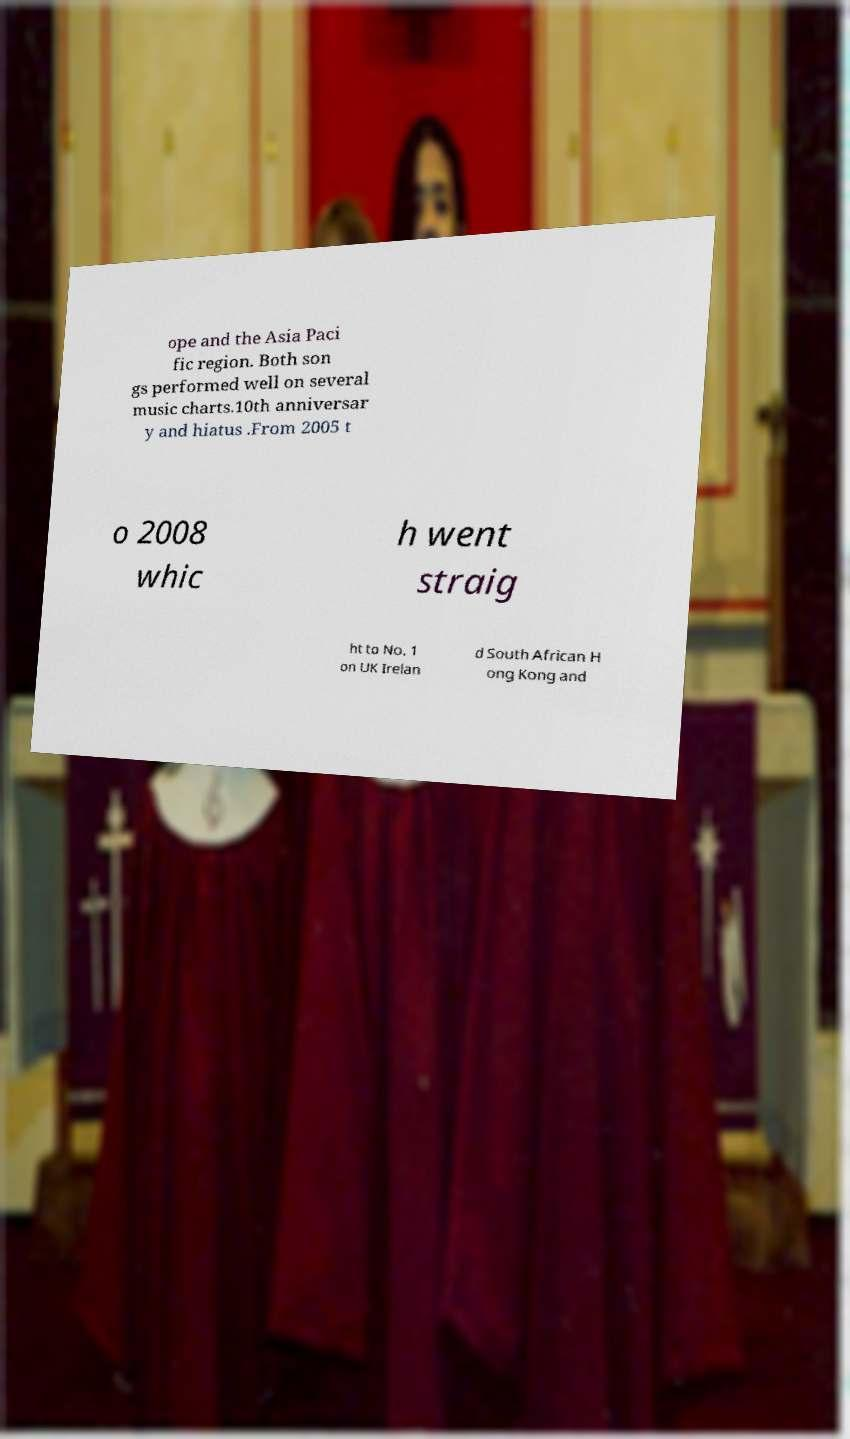Could you extract and type out the text from this image? ope and the Asia Paci fic region. Both son gs performed well on several music charts.10th anniversar y and hiatus .From 2005 t o 2008 whic h went straig ht to No. 1 on UK Irelan d South African H ong Kong and 